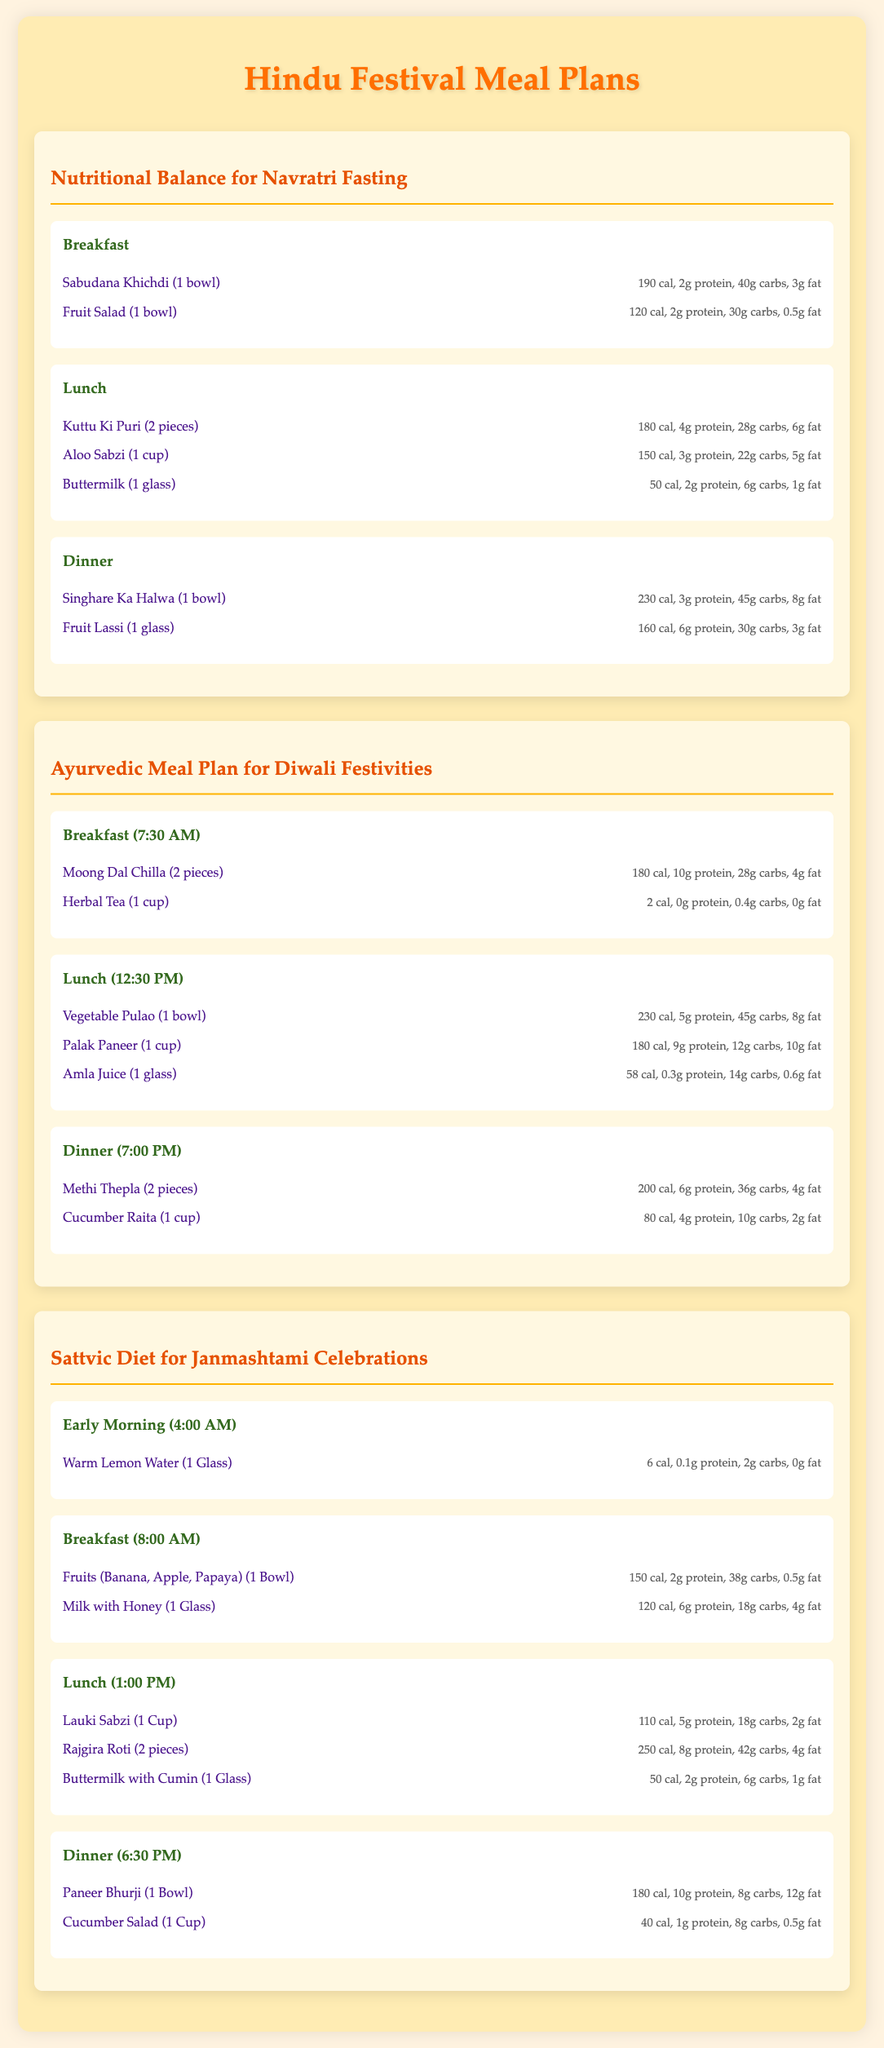What is the calorie count of Sabudana Khichdi? The calorie count of Sabudana Khichdi is listed under the breakfast section in the Navratri Fasting plan, which is 190 calories.
Answer: 190 cal How many pieces of Kuttu Ki Puri are recommended for lunch? The meal plan for lunch during Navratri specifies 2 pieces of Kuttu Ki Puri.
Answer: 2 pieces What is included in the breakfast for the Ayurvedic Meal Plan for Diwali? The breakfast includes Moong Dal Chilla and Herbal Tea, which are detailed under the meal section.
Answer: Moong Dal Chilla and Herbal Tea What time is lunch served during Janmashtami Celebrations? The meal plan indicates lunch is served at 1:00 PM during Janmashtami Celebrations.
Answer: 1:00 PM How much protein does a bowl of Paneer Bhurji contain? The nutritional breakdown specifies that Paneer Bhurji has 10 grams of protein per bowl, listed under the dinner section for Janmashtami.
Answer: 10g protein Which beverage is suggested as part of the early morning meal for Janmashtami? The early morning meal includes Warm Lemon Water as indicated in the meal section of the document.
Answer: Warm Lemon Water What is the total carbohydrate content of Aloo Sabzi? The nutritional details for Aloo Sabzi show it contains 22 grams of carbohydrates.
Answer: 22g carbs What is the total calorie count for a glass of Amla Juice during lunch in the Diwali plan? The document states that Amla Juice contains 58 calories, which can be found under the lunch section.
Answer: 58 cal What type of diet does the document recommend for Navratri? The document specifies a sattvic (pure and balanced) diet for meals during Navratri.
Answer: Sattvic diet 